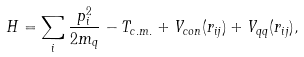<formula> <loc_0><loc_0><loc_500><loc_500>H = \sum _ { i } \frac { p _ { i } ^ { 2 } } { 2 m _ { q } } - T _ { c . m . } + V _ { c o n } ( { r } _ { i j } ) + V _ { q q } ( { r } _ { i j } ) ,</formula> 